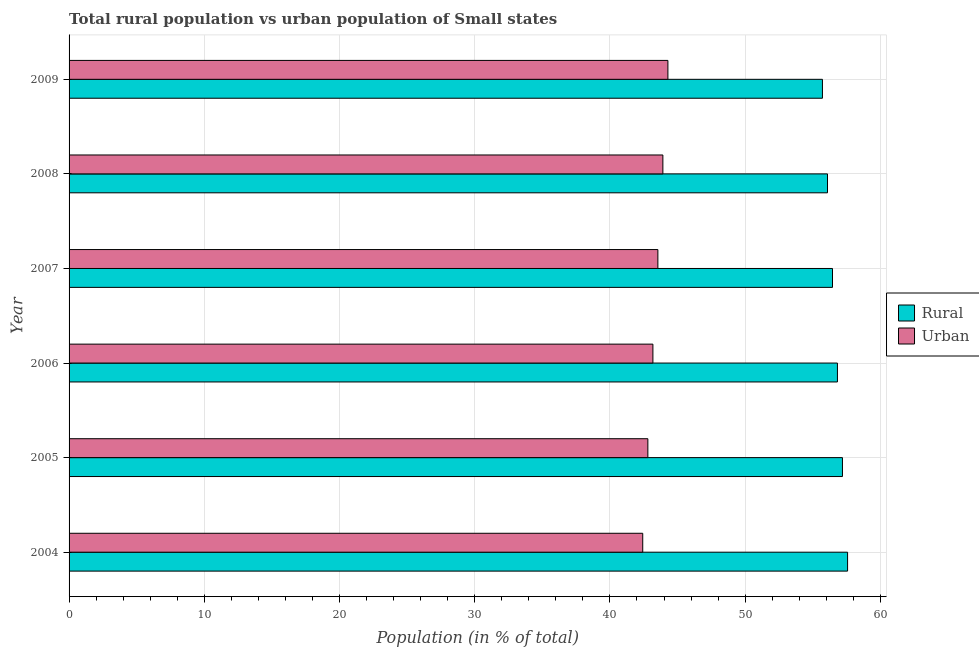How many different coloured bars are there?
Your response must be concise. 2. How many groups of bars are there?
Your answer should be very brief. 6. What is the label of the 4th group of bars from the top?
Offer a terse response. 2006. What is the urban population in 2008?
Keep it short and to the point. 43.92. Across all years, what is the maximum rural population?
Provide a succinct answer. 57.58. Across all years, what is the minimum rural population?
Your answer should be very brief. 55.72. In which year was the urban population maximum?
Keep it short and to the point. 2009. In which year was the rural population minimum?
Make the answer very short. 2009. What is the total rural population in the graph?
Give a very brief answer. 339.88. What is the difference between the urban population in 2005 and that in 2006?
Make the answer very short. -0.37. What is the difference between the rural population in 2009 and the urban population in 2005?
Your answer should be very brief. 12.91. What is the average rural population per year?
Ensure brevity in your answer.  56.65. In the year 2005, what is the difference between the urban population and rural population?
Provide a succinct answer. -14.39. In how many years, is the rural population greater than 34 %?
Give a very brief answer. 6. What is the ratio of the rural population in 2006 to that in 2007?
Provide a short and direct response. 1.01. Is the rural population in 2006 less than that in 2009?
Provide a succinct answer. No. Is the difference between the rural population in 2005 and 2008 greater than the difference between the urban population in 2005 and 2008?
Your answer should be very brief. Yes. What is the difference between the highest and the second highest urban population?
Your answer should be compact. 0.37. What is the difference between the highest and the lowest rural population?
Offer a very short reply. 1.86. In how many years, is the rural population greater than the average rural population taken over all years?
Ensure brevity in your answer.  3. Is the sum of the urban population in 2008 and 2009 greater than the maximum rural population across all years?
Your answer should be very brief. Yes. What does the 2nd bar from the top in 2006 represents?
Keep it short and to the point. Rural. What does the 2nd bar from the bottom in 2009 represents?
Keep it short and to the point. Urban. How many bars are there?
Provide a succinct answer. 12. How many years are there in the graph?
Your answer should be compact. 6. What is the difference between two consecutive major ticks on the X-axis?
Make the answer very short. 10. Are the values on the major ticks of X-axis written in scientific E-notation?
Your answer should be very brief. No. Does the graph contain any zero values?
Ensure brevity in your answer.  No. Does the graph contain grids?
Offer a terse response. Yes. How many legend labels are there?
Keep it short and to the point. 2. What is the title of the graph?
Ensure brevity in your answer.  Total rural population vs urban population of Small states. What is the label or title of the X-axis?
Your answer should be very brief. Population (in % of total). What is the Population (in % of total) of Rural in 2004?
Offer a very short reply. 57.58. What is the Population (in % of total) in Urban in 2004?
Make the answer very short. 42.43. What is the Population (in % of total) in Rural in 2005?
Give a very brief answer. 57.2. What is the Population (in % of total) in Urban in 2005?
Provide a short and direct response. 42.81. What is the Population (in % of total) of Rural in 2006?
Give a very brief answer. 56.83. What is the Population (in % of total) of Urban in 2006?
Offer a very short reply. 43.18. What is the Population (in % of total) of Rural in 2007?
Give a very brief answer. 56.46. What is the Population (in % of total) in Urban in 2007?
Provide a short and direct response. 43.55. What is the Population (in % of total) in Rural in 2008?
Give a very brief answer. 56.09. What is the Population (in % of total) in Urban in 2008?
Keep it short and to the point. 43.92. What is the Population (in % of total) of Rural in 2009?
Offer a terse response. 55.72. What is the Population (in % of total) of Urban in 2009?
Make the answer very short. 44.29. Across all years, what is the maximum Population (in % of total) of Rural?
Provide a succinct answer. 57.58. Across all years, what is the maximum Population (in % of total) of Urban?
Make the answer very short. 44.29. Across all years, what is the minimum Population (in % of total) in Rural?
Offer a very short reply. 55.72. Across all years, what is the minimum Population (in % of total) of Urban?
Offer a terse response. 42.43. What is the total Population (in % of total) of Rural in the graph?
Keep it short and to the point. 339.88. What is the total Population (in % of total) in Urban in the graph?
Give a very brief answer. 260.17. What is the difference between the Population (in % of total) of Rural in 2004 and that in 2005?
Provide a succinct answer. 0.38. What is the difference between the Population (in % of total) of Urban in 2004 and that in 2005?
Your answer should be very brief. -0.38. What is the difference between the Population (in % of total) in Rural in 2004 and that in 2006?
Make the answer very short. 0.75. What is the difference between the Population (in % of total) in Urban in 2004 and that in 2006?
Offer a very short reply. -0.75. What is the difference between the Population (in % of total) in Rural in 2004 and that in 2007?
Your answer should be very brief. 1.12. What is the difference between the Population (in % of total) in Urban in 2004 and that in 2007?
Provide a short and direct response. -1.12. What is the difference between the Population (in % of total) of Rural in 2004 and that in 2008?
Make the answer very short. 1.49. What is the difference between the Population (in % of total) in Urban in 2004 and that in 2008?
Your answer should be very brief. -1.49. What is the difference between the Population (in % of total) of Rural in 2004 and that in 2009?
Provide a short and direct response. 1.86. What is the difference between the Population (in % of total) in Urban in 2004 and that in 2009?
Ensure brevity in your answer.  -1.86. What is the difference between the Population (in % of total) of Rural in 2005 and that in 2006?
Provide a succinct answer. 0.37. What is the difference between the Population (in % of total) of Urban in 2005 and that in 2006?
Provide a short and direct response. -0.37. What is the difference between the Population (in % of total) of Rural in 2005 and that in 2007?
Your answer should be compact. 0.74. What is the difference between the Population (in % of total) of Urban in 2005 and that in 2007?
Give a very brief answer. -0.74. What is the difference between the Population (in % of total) of Rural in 2005 and that in 2008?
Give a very brief answer. 1.11. What is the difference between the Population (in % of total) of Urban in 2005 and that in 2008?
Keep it short and to the point. -1.11. What is the difference between the Population (in % of total) in Rural in 2005 and that in 2009?
Offer a very short reply. 1.48. What is the difference between the Population (in % of total) in Urban in 2005 and that in 2009?
Your answer should be very brief. -1.48. What is the difference between the Population (in % of total) in Rural in 2006 and that in 2007?
Your answer should be very brief. 0.37. What is the difference between the Population (in % of total) of Urban in 2006 and that in 2007?
Your response must be concise. -0.37. What is the difference between the Population (in % of total) of Rural in 2006 and that in 2008?
Your response must be concise. 0.73. What is the difference between the Population (in % of total) in Urban in 2006 and that in 2008?
Offer a very short reply. -0.74. What is the difference between the Population (in % of total) of Rural in 2006 and that in 2009?
Offer a terse response. 1.11. What is the difference between the Population (in % of total) of Urban in 2006 and that in 2009?
Make the answer very short. -1.11. What is the difference between the Population (in % of total) of Rural in 2007 and that in 2008?
Offer a terse response. 0.37. What is the difference between the Population (in % of total) of Urban in 2007 and that in 2008?
Offer a terse response. -0.37. What is the difference between the Population (in % of total) in Rural in 2007 and that in 2009?
Provide a short and direct response. 0.74. What is the difference between the Population (in % of total) of Urban in 2007 and that in 2009?
Give a very brief answer. -0.74. What is the difference between the Population (in % of total) of Rural in 2008 and that in 2009?
Offer a terse response. 0.37. What is the difference between the Population (in % of total) of Urban in 2008 and that in 2009?
Offer a terse response. -0.37. What is the difference between the Population (in % of total) of Rural in 2004 and the Population (in % of total) of Urban in 2005?
Make the answer very short. 14.77. What is the difference between the Population (in % of total) in Rural in 2004 and the Population (in % of total) in Urban in 2006?
Ensure brevity in your answer.  14.4. What is the difference between the Population (in % of total) in Rural in 2004 and the Population (in % of total) in Urban in 2007?
Your response must be concise. 14.03. What is the difference between the Population (in % of total) in Rural in 2004 and the Population (in % of total) in Urban in 2008?
Your response must be concise. 13.66. What is the difference between the Population (in % of total) of Rural in 2004 and the Population (in % of total) of Urban in 2009?
Give a very brief answer. 13.29. What is the difference between the Population (in % of total) in Rural in 2005 and the Population (in % of total) in Urban in 2006?
Ensure brevity in your answer.  14.02. What is the difference between the Population (in % of total) of Rural in 2005 and the Population (in % of total) of Urban in 2007?
Offer a very short reply. 13.65. What is the difference between the Population (in % of total) in Rural in 2005 and the Population (in % of total) in Urban in 2008?
Provide a short and direct response. 13.28. What is the difference between the Population (in % of total) in Rural in 2005 and the Population (in % of total) in Urban in 2009?
Your answer should be compact. 12.91. What is the difference between the Population (in % of total) in Rural in 2006 and the Population (in % of total) in Urban in 2007?
Offer a terse response. 13.28. What is the difference between the Population (in % of total) in Rural in 2006 and the Population (in % of total) in Urban in 2008?
Keep it short and to the point. 12.91. What is the difference between the Population (in % of total) in Rural in 2006 and the Population (in % of total) in Urban in 2009?
Offer a terse response. 12.54. What is the difference between the Population (in % of total) of Rural in 2007 and the Population (in % of total) of Urban in 2008?
Provide a short and direct response. 12.54. What is the difference between the Population (in % of total) of Rural in 2007 and the Population (in % of total) of Urban in 2009?
Keep it short and to the point. 12.17. What is the difference between the Population (in % of total) of Rural in 2008 and the Population (in % of total) of Urban in 2009?
Your answer should be very brief. 11.8. What is the average Population (in % of total) in Rural per year?
Your answer should be compact. 56.65. What is the average Population (in % of total) in Urban per year?
Your answer should be compact. 43.36. In the year 2004, what is the difference between the Population (in % of total) of Rural and Population (in % of total) of Urban?
Provide a succinct answer. 15.15. In the year 2005, what is the difference between the Population (in % of total) in Rural and Population (in % of total) in Urban?
Ensure brevity in your answer.  14.39. In the year 2006, what is the difference between the Population (in % of total) of Rural and Population (in % of total) of Urban?
Keep it short and to the point. 13.65. In the year 2007, what is the difference between the Population (in % of total) of Rural and Population (in % of total) of Urban?
Keep it short and to the point. 12.91. In the year 2008, what is the difference between the Population (in % of total) of Rural and Population (in % of total) of Urban?
Offer a terse response. 12.17. In the year 2009, what is the difference between the Population (in % of total) of Rural and Population (in % of total) of Urban?
Provide a short and direct response. 11.43. What is the ratio of the Population (in % of total) of Rural in 2004 to that in 2005?
Your answer should be compact. 1.01. What is the ratio of the Population (in % of total) in Urban in 2004 to that in 2005?
Offer a very short reply. 0.99. What is the ratio of the Population (in % of total) of Rural in 2004 to that in 2006?
Your response must be concise. 1.01. What is the ratio of the Population (in % of total) in Urban in 2004 to that in 2006?
Keep it short and to the point. 0.98. What is the ratio of the Population (in % of total) in Rural in 2004 to that in 2007?
Your answer should be very brief. 1.02. What is the ratio of the Population (in % of total) of Urban in 2004 to that in 2007?
Make the answer very short. 0.97. What is the ratio of the Population (in % of total) in Rural in 2004 to that in 2008?
Give a very brief answer. 1.03. What is the ratio of the Population (in % of total) of Urban in 2004 to that in 2008?
Your answer should be very brief. 0.97. What is the ratio of the Population (in % of total) of Rural in 2004 to that in 2009?
Provide a succinct answer. 1.03. What is the ratio of the Population (in % of total) in Urban in 2004 to that in 2009?
Your response must be concise. 0.96. What is the ratio of the Population (in % of total) of Rural in 2005 to that in 2007?
Provide a succinct answer. 1.01. What is the ratio of the Population (in % of total) in Urban in 2005 to that in 2007?
Give a very brief answer. 0.98. What is the ratio of the Population (in % of total) of Rural in 2005 to that in 2008?
Keep it short and to the point. 1.02. What is the ratio of the Population (in % of total) of Urban in 2005 to that in 2008?
Provide a short and direct response. 0.97. What is the ratio of the Population (in % of total) in Rural in 2005 to that in 2009?
Your answer should be very brief. 1.03. What is the ratio of the Population (in % of total) in Urban in 2005 to that in 2009?
Give a very brief answer. 0.97. What is the ratio of the Population (in % of total) in Rural in 2006 to that in 2007?
Provide a succinct answer. 1.01. What is the ratio of the Population (in % of total) of Rural in 2006 to that in 2008?
Make the answer very short. 1.01. What is the ratio of the Population (in % of total) of Urban in 2006 to that in 2008?
Ensure brevity in your answer.  0.98. What is the ratio of the Population (in % of total) of Rural in 2006 to that in 2009?
Your answer should be compact. 1.02. What is the ratio of the Population (in % of total) in Urban in 2006 to that in 2009?
Provide a short and direct response. 0.97. What is the ratio of the Population (in % of total) in Rural in 2007 to that in 2008?
Provide a succinct answer. 1.01. What is the ratio of the Population (in % of total) in Urban in 2007 to that in 2008?
Offer a very short reply. 0.99. What is the ratio of the Population (in % of total) in Rural in 2007 to that in 2009?
Offer a very short reply. 1.01. What is the ratio of the Population (in % of total) in Urban in 2007 to that in 2009?
Ensure brevity in your answer.  0.98. What is the ratio of the Population (in % of total) of Rural in 2008 to that in 2009?
Your answer should be compact. 1.01. What is the difference between the highest and the second highest Population (in % of total) in Rural?
Offer a very short reply. 0.38. What is the difference between the highest and the second highest Population (in % of total) of Urban?
Your answer should be very brief. 0.37. What is the difference between the highest and the lowest Population (in % of total) in Rural?
Ensure brevity in your answer.  1.86. What is the difference between the highest and the lowest Population (in % of total) in Urban?
Your answer should be compact. 1.86. 